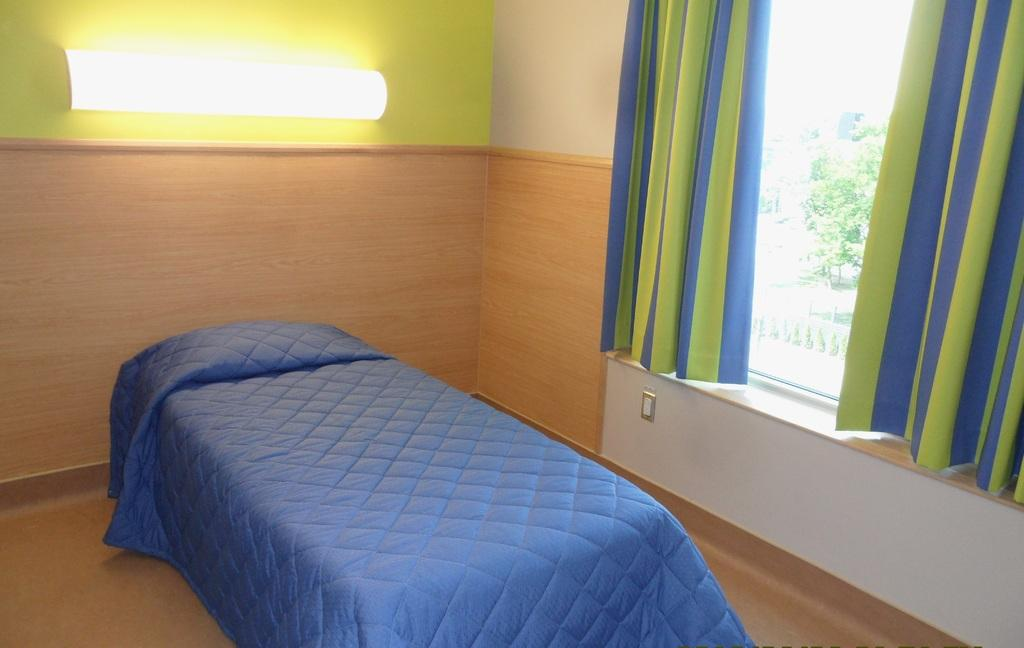What piece of furniture is present in the picture? There is a bed in the picture. What is covering the bed? There is a blanket on the bed. Can you describe the lighting in the picture? There is a light side in the picture. Where is the window located in the picture? There is a window on the right side of the picture. What can be seen through the window? Trees are visible through the window. What type of watch is visible on the bed? There is no watch present in the image. Can you describe the apple on the bed? There is no apple present in the image. 